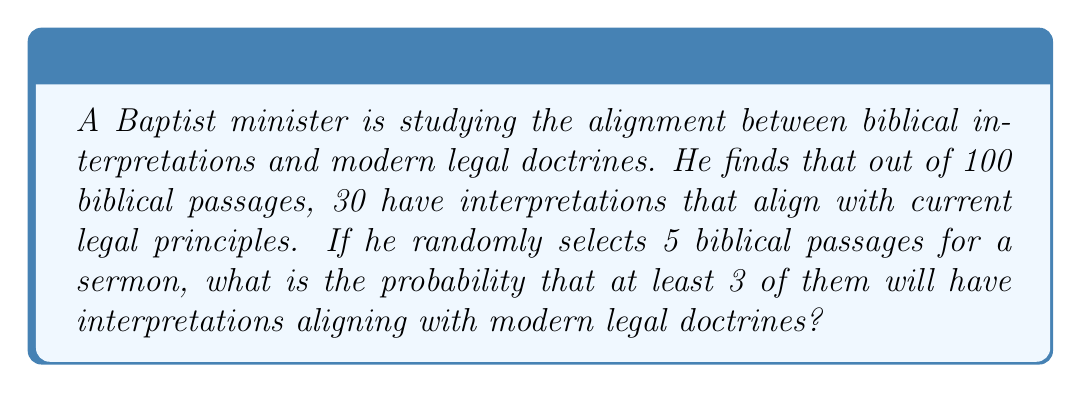Give your solution to this math problem. Let's approach this step-by-step using the binomial probability distribution:

1) First, we need to calculate the probability of a single passage aligning with legal doctrines:
   $p = \frac{30}{100} = 0.3$

2) The probability of not aligning is:
   $q = 1 - p = 0.7$

3) We want the probability of at least 3 out of 5 passages aligning. This means we need to calculate the probability of 3, 4, or 5 passages aligning and sum these probabilities.

4) We can use the binomial probability formula:
   $P(X = k) = \binom{n}{k} p^k q^{n-k}$
   where $n = 5$ (total passages), $k = 3, 4, 5$ (number of aligned passages)

5) Let's calculate each probability:

   For $k = 3$:
   $P(X = 3) = \binom{5}{3} (0.3)^3 (0.7)^2 = 10 \cdot 0.027 \cdot 0.49 = 0.1323$

   For $k = 4$:
   $P(X = 4) = \binom{5}{4} (0.3)^4 (0.7)^1 = 5 \cdot 0.0081 \cdot 0.7 = 0.02835$

   For $k = 5$:
   $P(X = 5) = \binom{5}{5} (0.3)^5 (0.7)^0 = 1 \cdot 0.00243 \cdot 1 = 0.00243$

6) Now, we sum these probabilities:
   $P(X \geq 3) = P(X = 3) + P(X = 4) + P(X = 5)$
   $= 0.1323 + 0.02835 + 0.00243$
   $= 0.16308$

Therefore, the probability is approximately 0.16308 or 16.31%.
Answer: 0.16308 